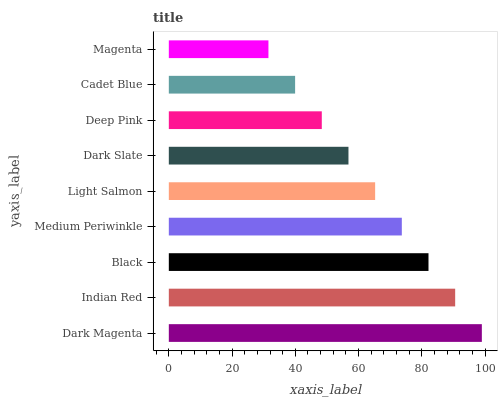Is Magenta the minimum?
Answer yes or no. Yes. Is Dark Magenta the maximum?
Answer yes or no. Yes. Is Indian Red the minimum?
Answer yes or no. No. Is Indian Red the maximum?
Answer yes or no. No. Is Dark Magenta greater than Indian Red?
Answer yes or no. Yes. Is Indian Red less than Dark Magenta?
Answer yes or no. Yes. Is Indian Red greater than Dark Magenta?
Answer yes or no. No. Is Dark Magenta less than Indian Red?
Answer yes or no. No. Is Light Salmon the high median?
Answer yes or no. Yes. Is Light Salmon the low median?
Answer yes or no. Yes. Is Cadet Blue the high median?
Answer yes or no. No. Is Dark Slate the low median?
Answer yes or no. No. 